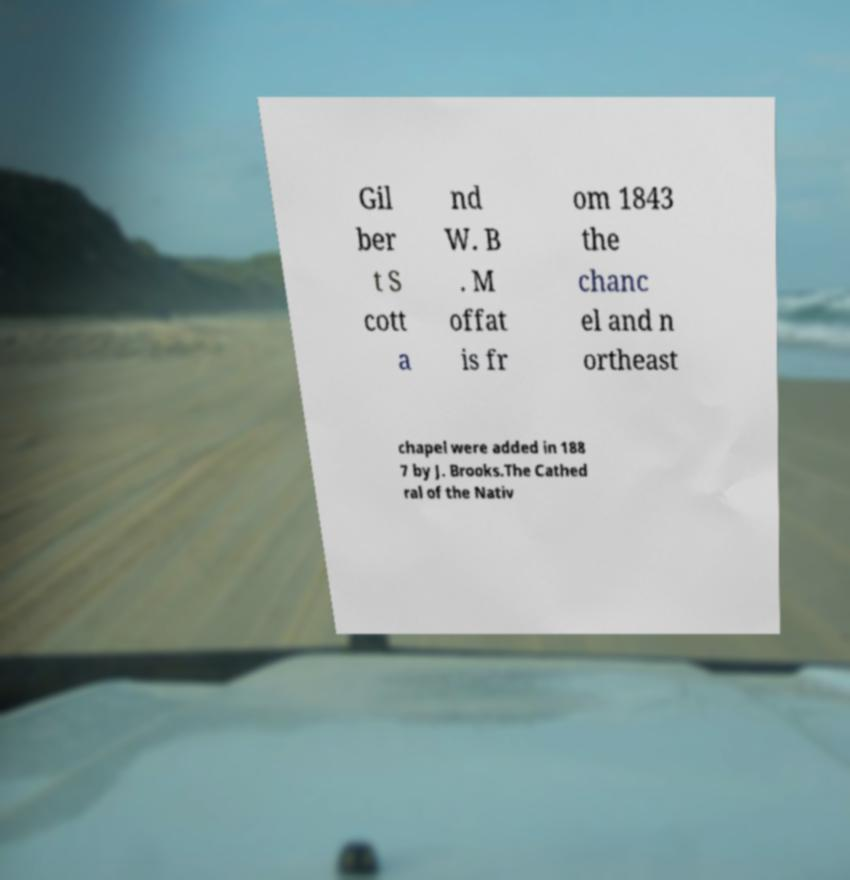What messages or text are displayed in this image? I need them in a readable, typed format. Gil ber t S cott a nd W. B . M offat is fr om 1843 the chanc el and n ortheast chapel were added in 188 7 by J. Brooks.The Cathed ral of the Nativ 